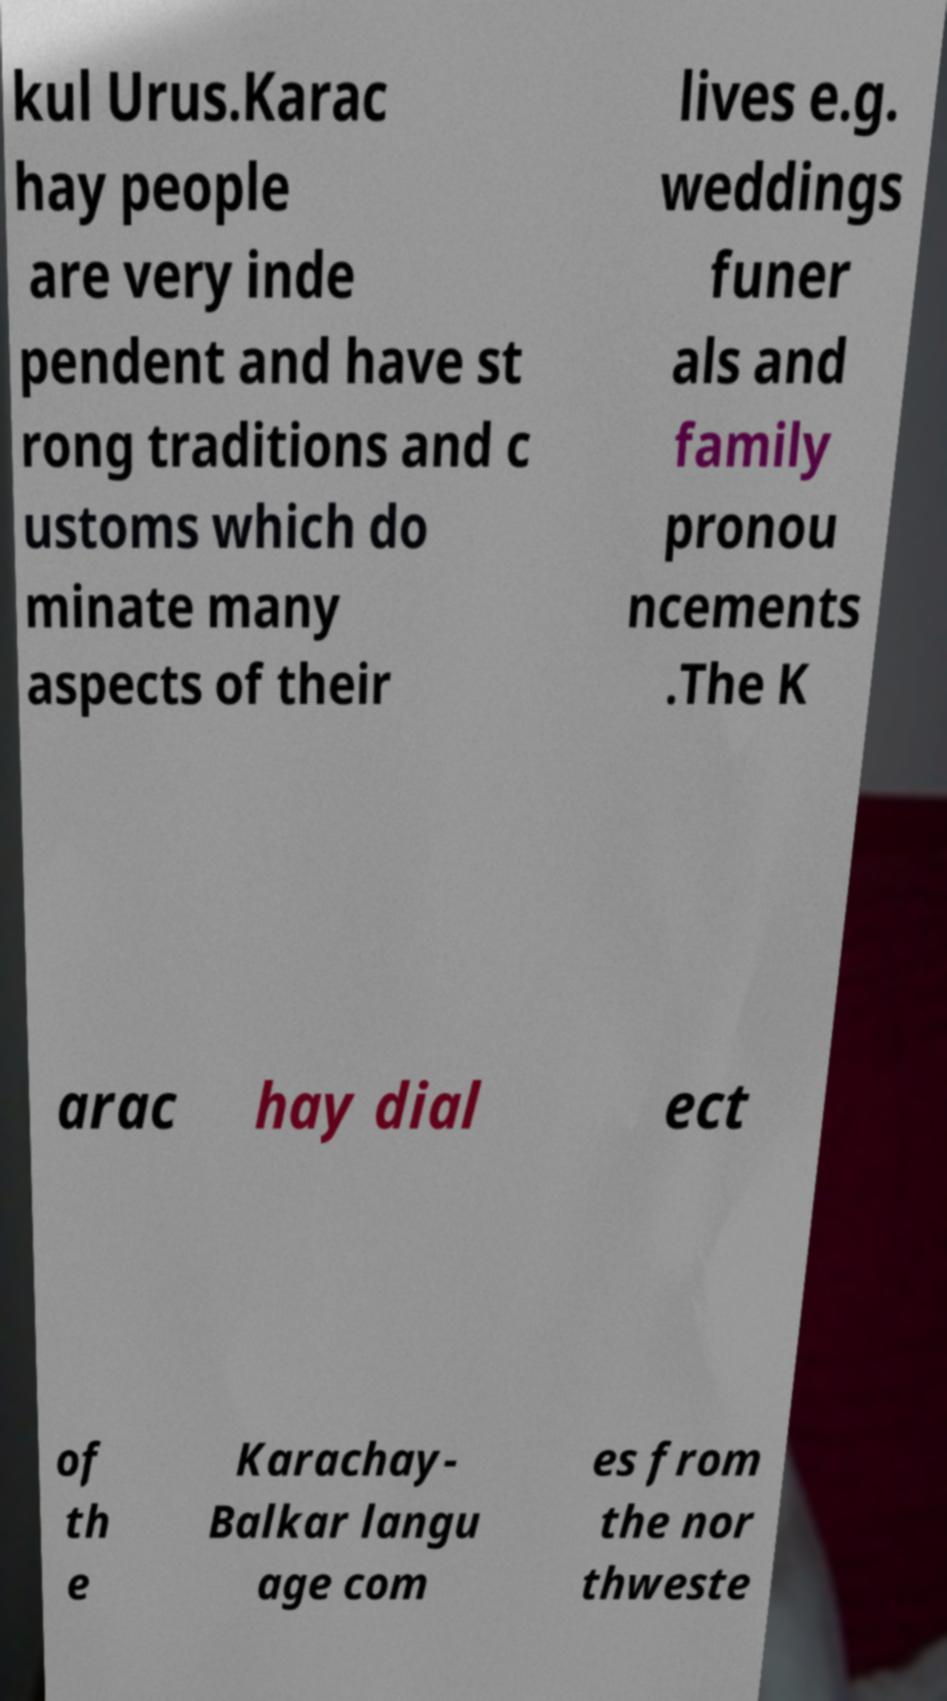Can you read and provide the text displayed in the image?This photo seems to have some interesting text. Can you extract and type it out for me? kul Urus.Karac hay people are very inde pendent and have st rong traditions and c ustoms which do minate many aspects of their lives e.g. weddings funer als and family pronou ncements .The K arac hay dial ect of th e Karachay- Balkar langu age com es from the nor thweste 